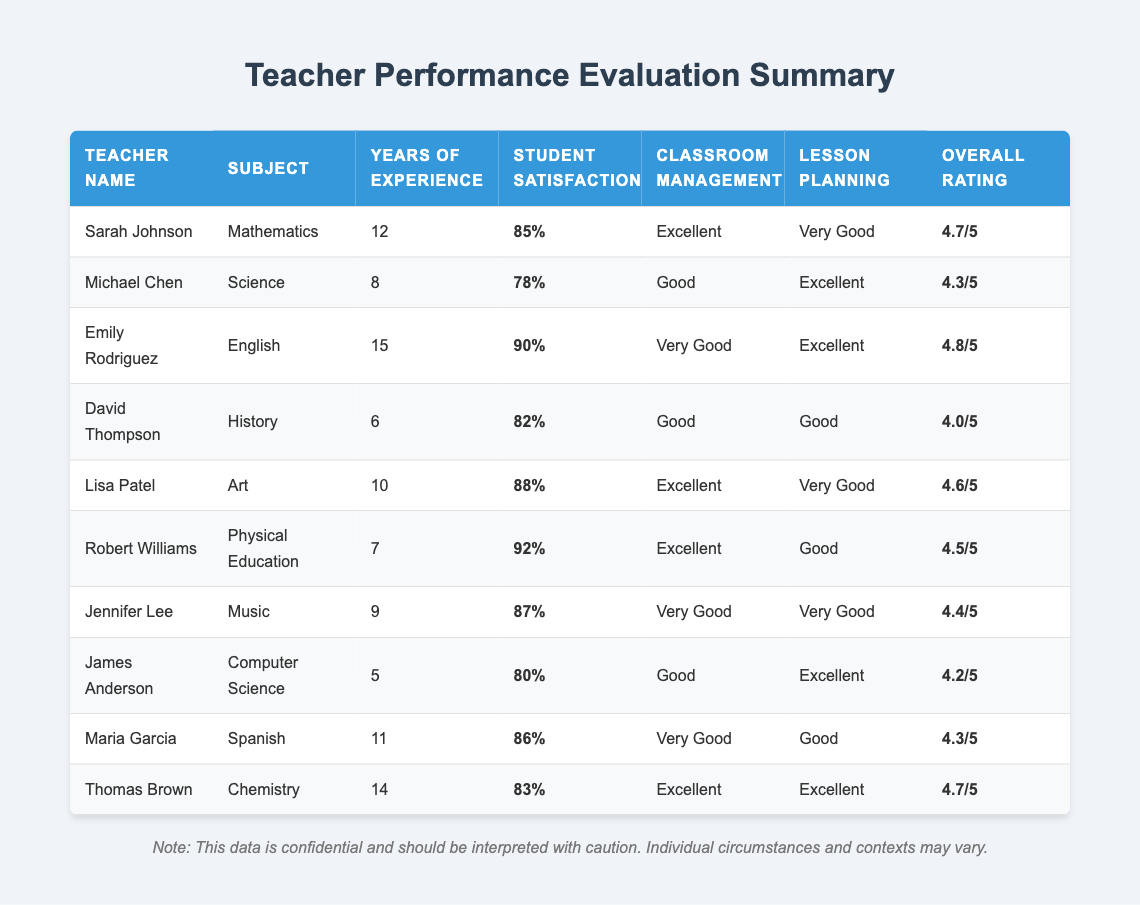What is the overall rating for Emily Rodriguez? Looking at the row for Emily Rodriguez, the overall rating is listed as 4.8/5.
Answer: 4.8/5 How many years of experience does Sarah Johnson have? Sarah Johnson's row indicates she has 12 years of experience.
Answer: 12 Which teacher has the highest student satisfaction percentage? Reviewing the student satisfaction percentages, Robert Williams has the highest at 92%.
Answer: 92% Is it true that Jennifer Lee has more years of experience than David Thompson? Jennifer Lee has 9 years of experience, while David Thompson has 6 years. Since 9 is greater than 6, the statement is true.
Answer: Yes What is the average overall rating for teachers with more than 10 years of experience? The teachers with more than 10 years of experience are: Emily Rodriguez (4.8), Sarah Johnson (4.7), and Thomas Brown (4.7). Summing these gives 14.2, and there are 3 teachers, so the average is 14.2/3 = 4.73.
Answer: 4.73 Which subject does Michael Chen teach and what is his classroom management rating? Michael Chen teaches Science and his classroom management is rated as Good.
Answer: Science, Good Are there any teachers with an overall rating below 4.0? A review of the table shows that David Thompson has the lowest overall rating, which is 4.0. Therefore, no teachers have a rating below 4.0.
Answer: No Which teacher has both an excellent rating in classroom management and lesson planning? Looking at the table, Sarah Johnson and Thomas Brown both have "Excellent" in classroom management and lesson planning.
Answer: Sarah Johnson, Thomas Brown What is the difference in student satisfaction between Robert Williams and James Anderson? Robert Williams has a student satisfaction of 92%, and James Anderson has 80%. The difference is 92 - 80 = 12%.
Answer: 12% 